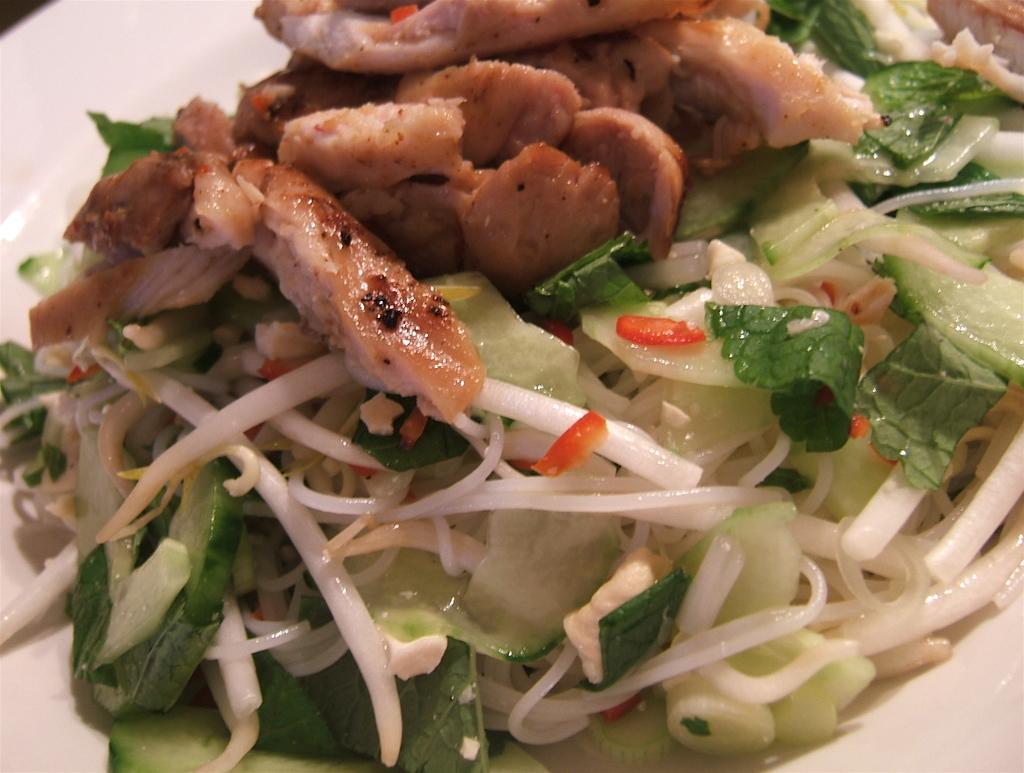How would you summarize this image in a sentence or two? In this picture there is a food on the white color plate. 